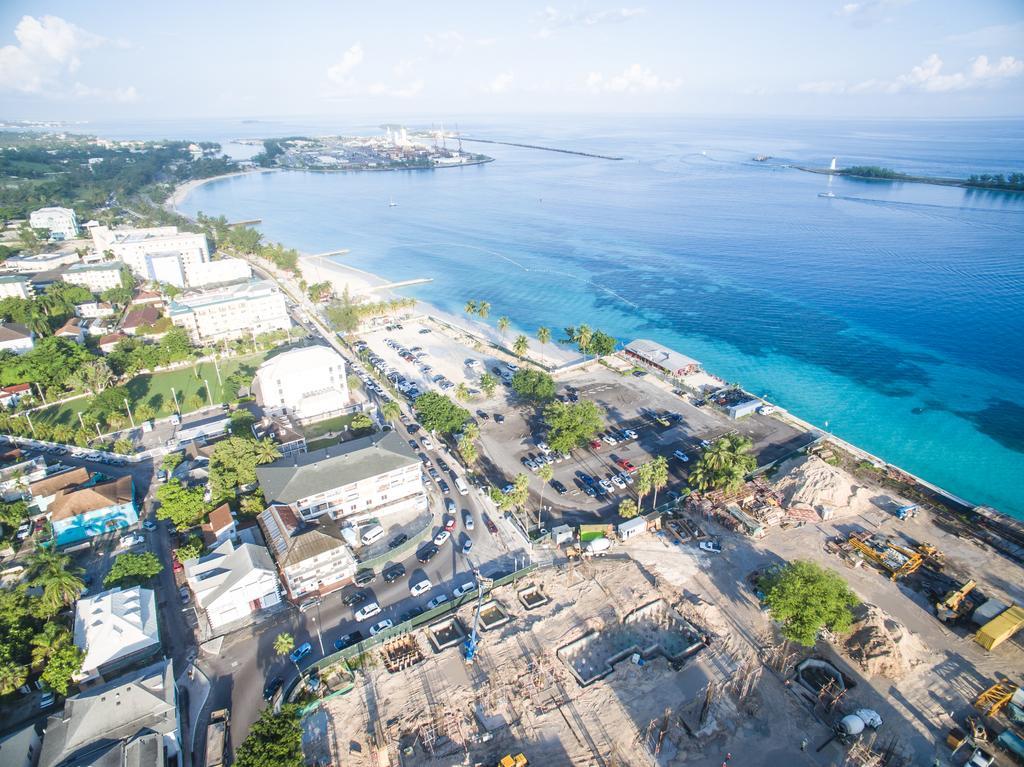Please provide a concise description of this image. This picture consists of an aerial view, where we can see houses, trees, vehicles, poles, and water in the image and there is sky. 